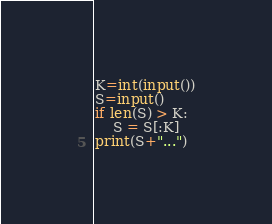<code> <loc_0><loc_0><loc_500><loc_500><_Python_>K=int(input())
S=input()
if len(S) > K:
	S = S[:K]
print(S+"...")</code> 